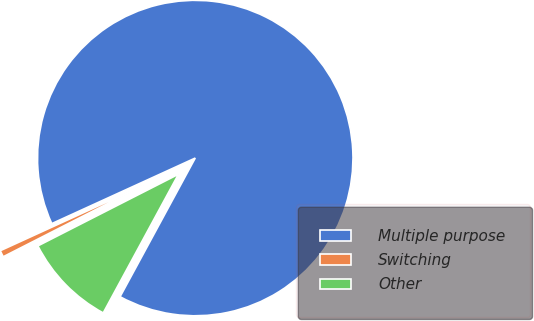Convert chart. <chart><loc_0><loc_0><loc_500><loc_500><pie_chart><fcel>Multiple purpose<fcel>Switching<fcel>Other<nl><fcel>89.73%<fcel>0.68%<fcel>9.59%<nl></chart> 